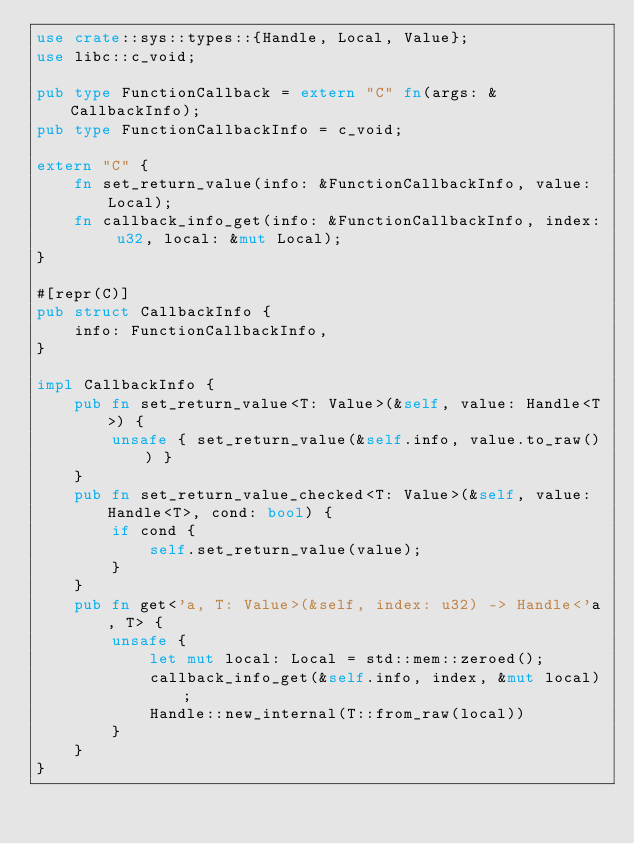Convert code to text. <code><loc_0><loc_0><loc_500><loc_500><_Rust_>use crate::sys::types::{Handle, Local, Value};
use libc::c_void;

pub type FunctionCallback = extern "C" fn(args: &CallbackInfo);
pub type FunctionCallbackInfo = c_void;

extern "C" {
    fn set_return_value(info: &FunctionCallbackInfo, value: Local);
    fn callback_info_get(info: &FunctionCallbackInfo, index: u32, local: &mut Local);
}

#[repr(C)]
pub struct CallbackInfo {
    info: FunctionCallbackInfo,
}

impl CallbackInfo {
    pub fn set_return_value<T: Value>(&self, value: Handle<T>) {
        unsafe { set_return_value(&self.info, value.to_raw()) }
    }
    pub fn set_return_value_checked<T: Value>(&self, value: Handle<T>, cond: bool) {
        if cond {
            self.set_return_value(value);
        }
    }
    pub fn get<'a, T: Value>(&self, index: u32) -> Handle<'a, T> {
        unsafe {
            let mut local: Local = std::mem::zeroed();
            callback_info_get(&self.info, index, &mut local);
            Handle::new_internal(T::from_raw(local))
        }
    }
}
</code> 